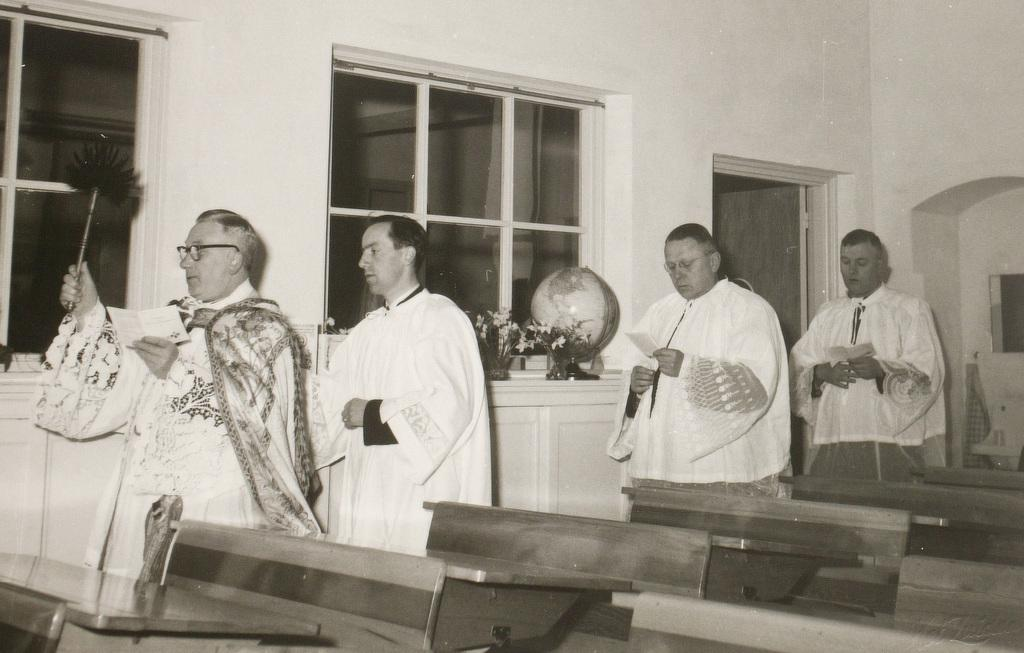How many people are standing in a line in the image? There are 4 people standing in a line in the image. What are the people holding in the image? The people are holding something, but the facts do not specify what they are holding. What type of furniture can be seen in the image? There are many chairs and tables in the image. What architectural feature is visible in the image? There are windows in the image. What type of sail can be seen in the image? There is no sail present in the image. What kind of pets are visible in the image? There are no pets visible in the image. 